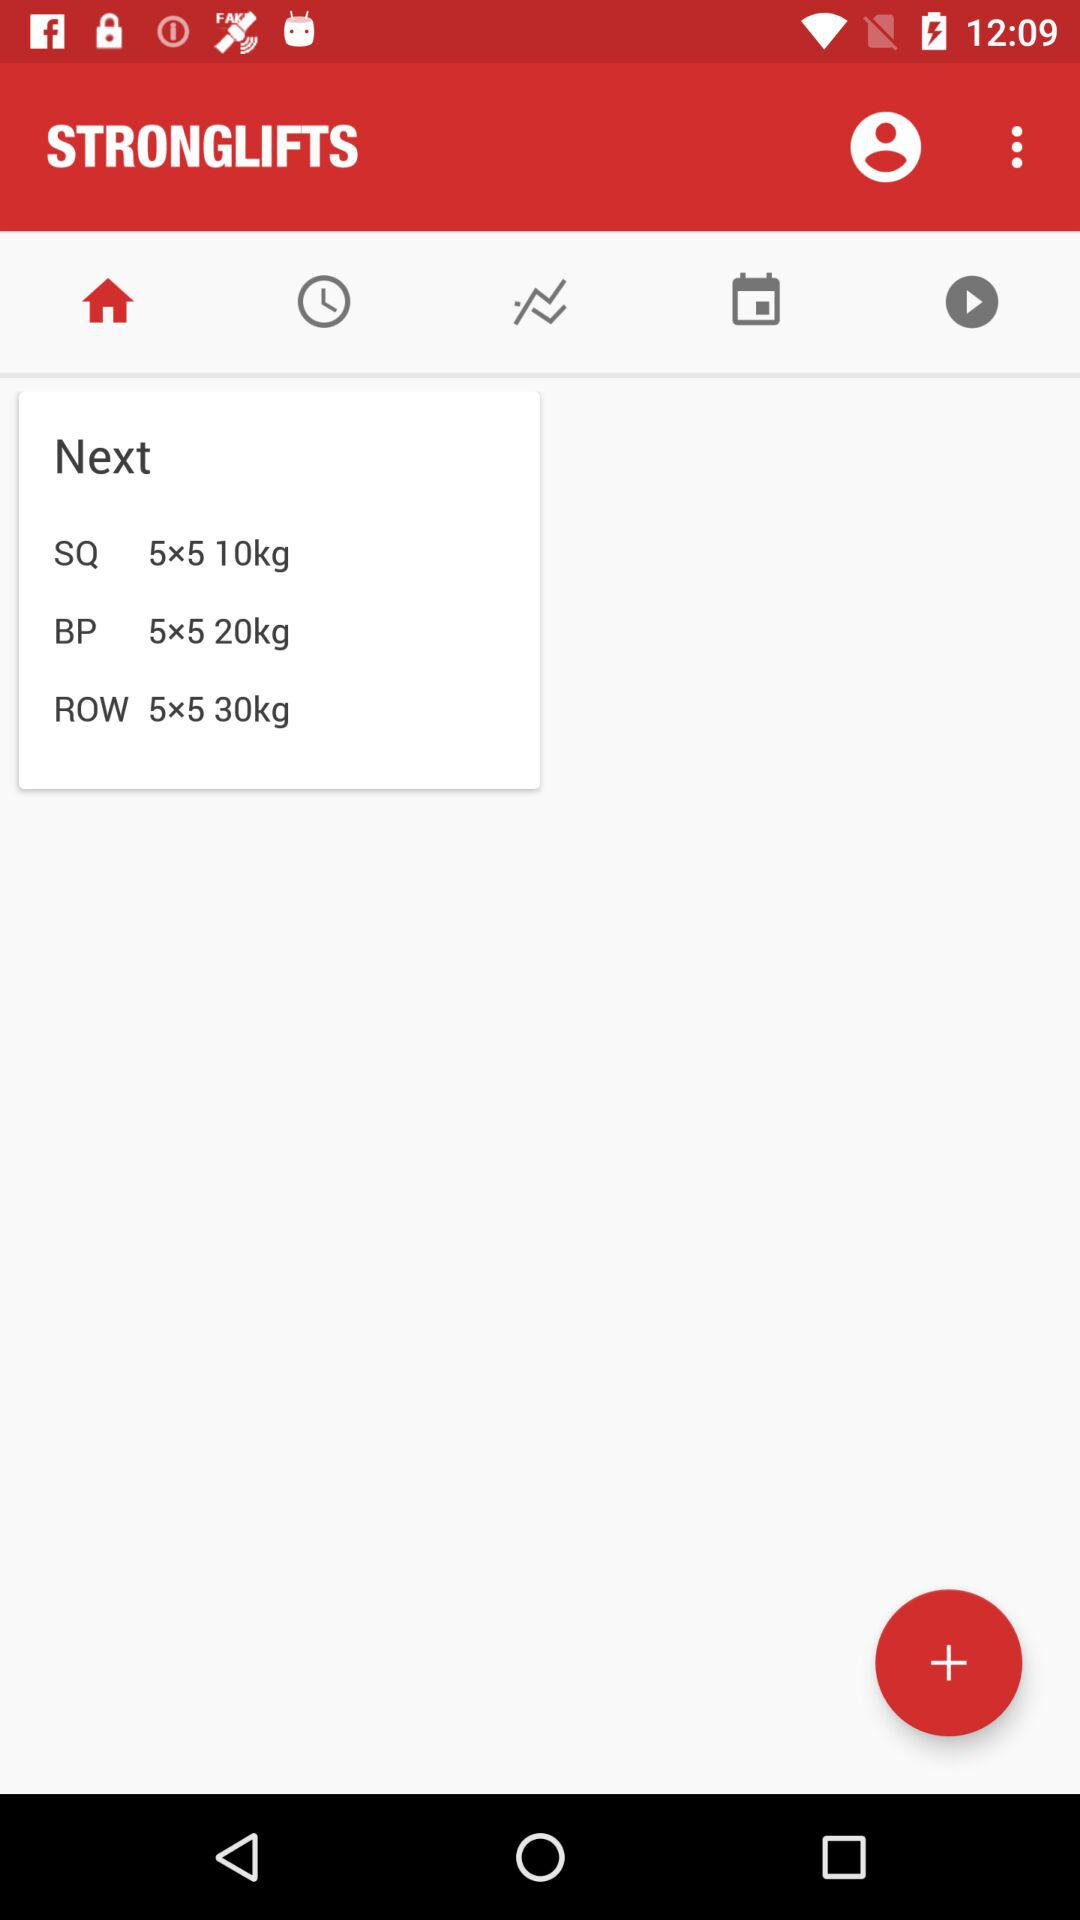How many kg is the average of the three exercises?
Answer the question using a single word or phrase. 20 